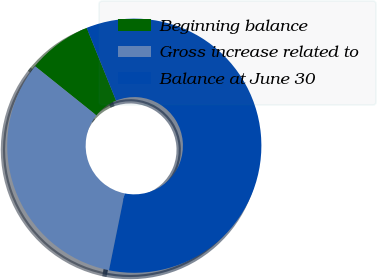Convert chart. <chart><loc_0><loc_0><loc_500><loc_500><pie_chart><fcel>Beginning balance<fcel>Gross increase related to<fcel>Balance at June 30<nl><fcel>8.14%<fcel>32.56%<fcel>59.3%<nl></chart> 